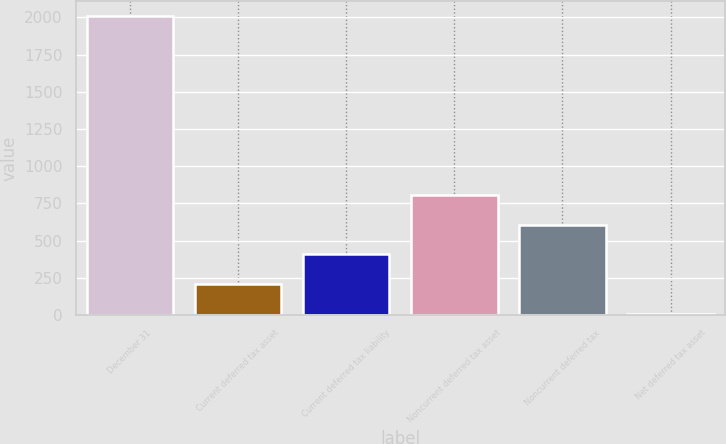Convert chart. <chart><loc_0><loc_0><loc_500><loc_500><bar_chart><fcel>December 31<fcel>Current deferred tax asset<fcel>Current deferred tax liability<fcel>Noncurrent deferred tax asset<fcel>Noncurrent deferred tax<fcel>Net deferred tax asset<nl><fcel>2008<fcel>207.1<fcel>407.2<fcel>807.4<fcel>607.3<fcel>7<nl></chart> 